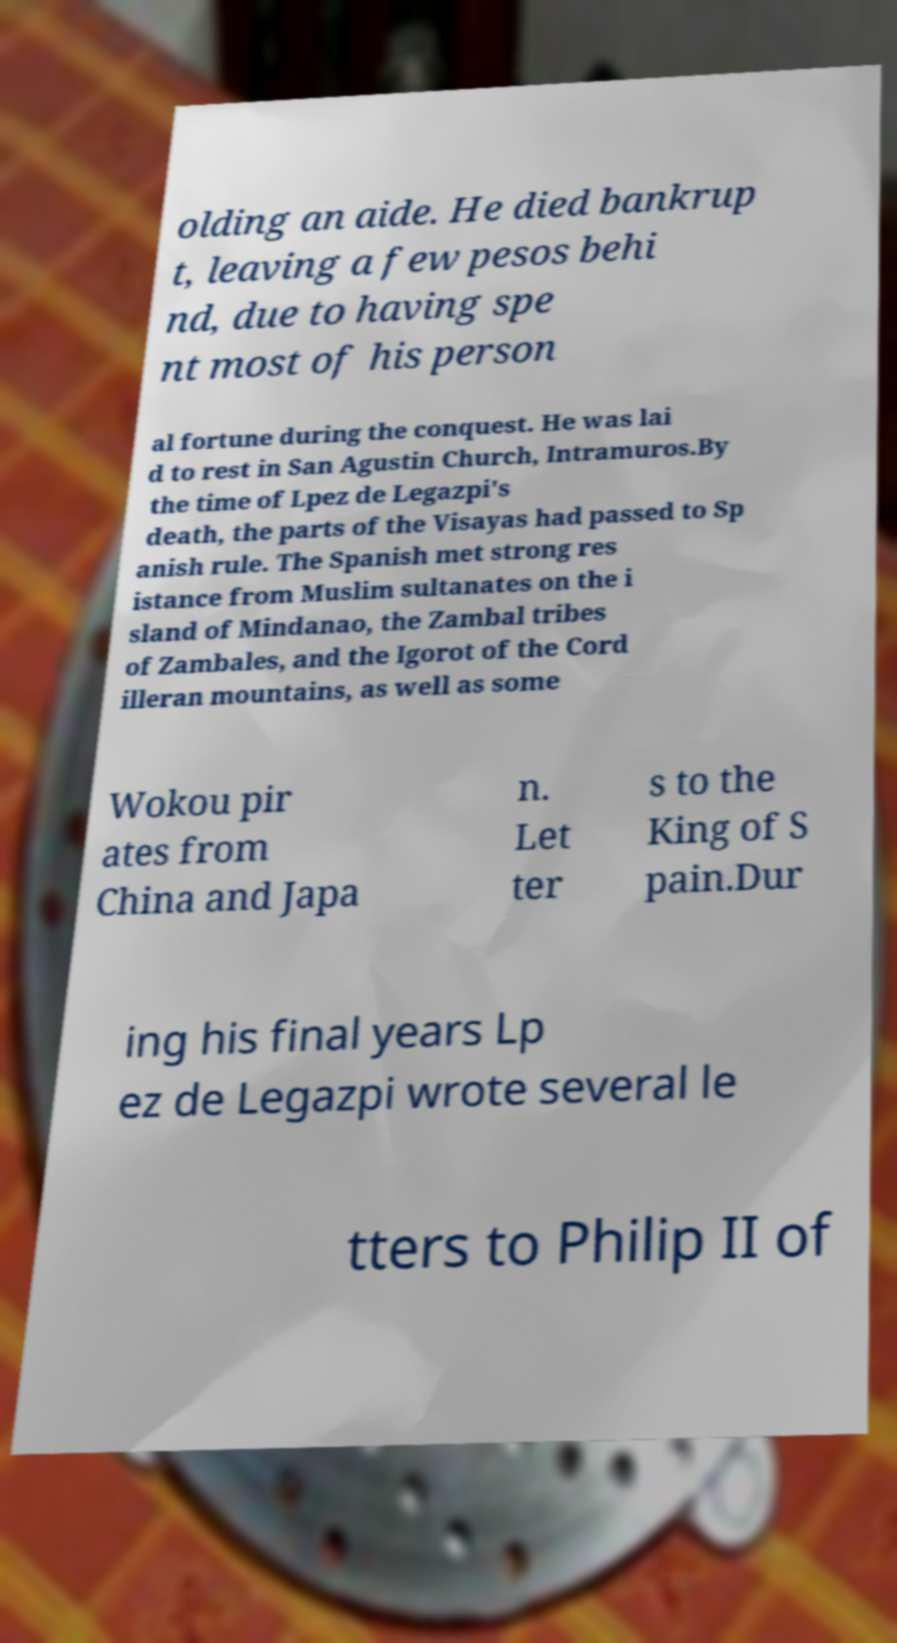Can you read and provide the text displayed in the image?This photo seems to have some interesting text. Can you extract and type it out for me? olding an aide. He died bankrup t, leaving a few pesos behi nd, due to having spe nt most of his person al fortune during the conquest. He was lai d to rest in San Agustin Church, Intramuros.By the time of Lpez de Legazpi's death, the parts of the Visayas had passed to Sp anish rule. The Spanish met strong res istance from Muslim sultanates on the i sland of Mindanao, the Zambal tribes of Zambales, and the Igorot of the Cord illeran mountains, as well as some Wokou pir ates from China and Japa n. Let ter s to the King of S pain.Dur ing his final years Lp ez de Legazpi wrote several le tters to Philip II of 